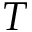<formula> <loc_0><loc_0><loc_500><loc_500>T</formula> 